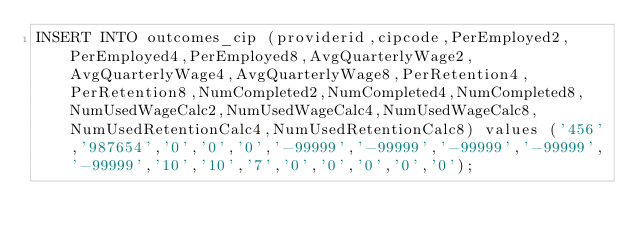Convert code to text. <code><loc_0><loc_0><loc_500><loc_500><_SQL_>INSERT INTO outcomes_cip (providerid,cipcode,PerEmployed2,PerEmployed4,PerEmployed8,AvgQuarterlyWage2,AvgQuarterlyWage4,AvgQuarterlyWage8,PerRetention4,PerRetention8,NumCompleted2,NumCompleted4,NumCompleted8,NumUsedWageCalc2,NumUsedWageCalc4,NumUsedWageCalc8,NumUsedRetentionCalc4,NumUsedRetentionCalc8) values ('456','987654','0','0','0','-99999','-99999','-99999','-99999','-99999','10','10','7','0','0','0','0','0');</code> 